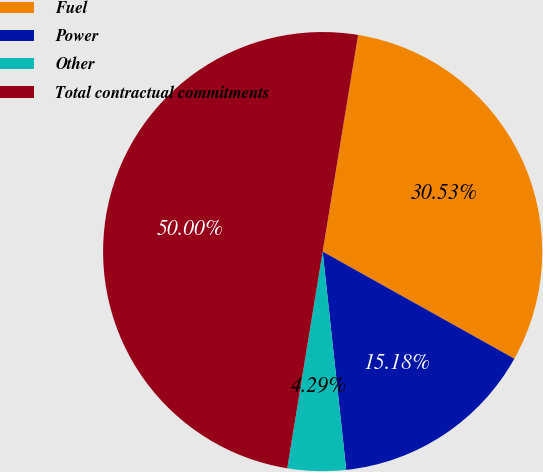Convert chart. <chart><loc_0><loc_0><loc_500><loc_500><pie_chart><fcel>Fuel<fcel>Power<fcel>Other<fcel>Total contractual commitments<nl><fcel>30.53%<fcel>15.18%<fcel>4.29%<fcel>50.0%<nl></chart> 